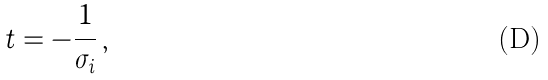Convert formula to latex. <formula><loc_0><loc_0><loc_500><loc_500>t = - \frac { 1 } { \sigma _ { i } } \, ,</formula> 